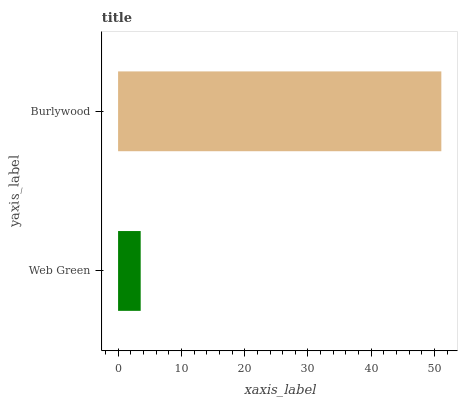Is Web Green the minimum?
Answer yes or no. Yes. Is Burlywood the maximum?
Answer yes or no. Yes. Is Burlywood the minimum?
Answer yes or no. No. Is Burlywood greater than Web Green?
Answer yes or no. Yes. Is Web Green less than Burlywood?
Answer yes or no. Yes. Is Web Green greater than Burlywood?
Answer yes or no. No. Is Burlywood less than Web Green?
Answer yes or no. No. Is Burlywood the high median?
Answer yes or no. Yes. Is Web Green the low median?
Answer yes or no. Yes. Is Web Green the high median?
Answer yes or no. No. Is Burlywood the low median?
Answer yes or no. No. 